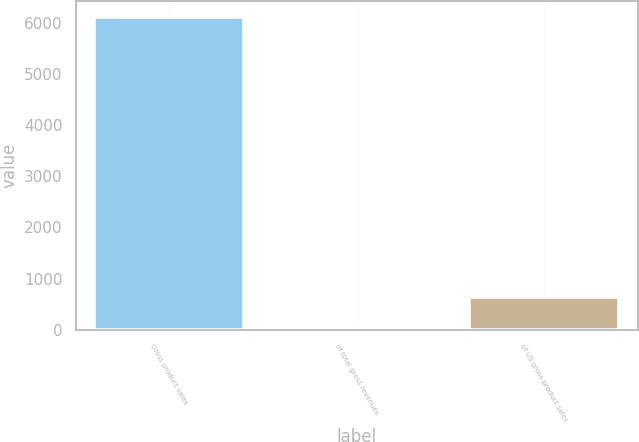<chart> <loc_0><loc_0><loc_500><loc_500><bar_chart><fcel>Gross product sales<fcel>of total gross revenues<fcel>of US gross product sales<nl><fcel>6124<fcel>31<fcel>640.3<nl></chart> 